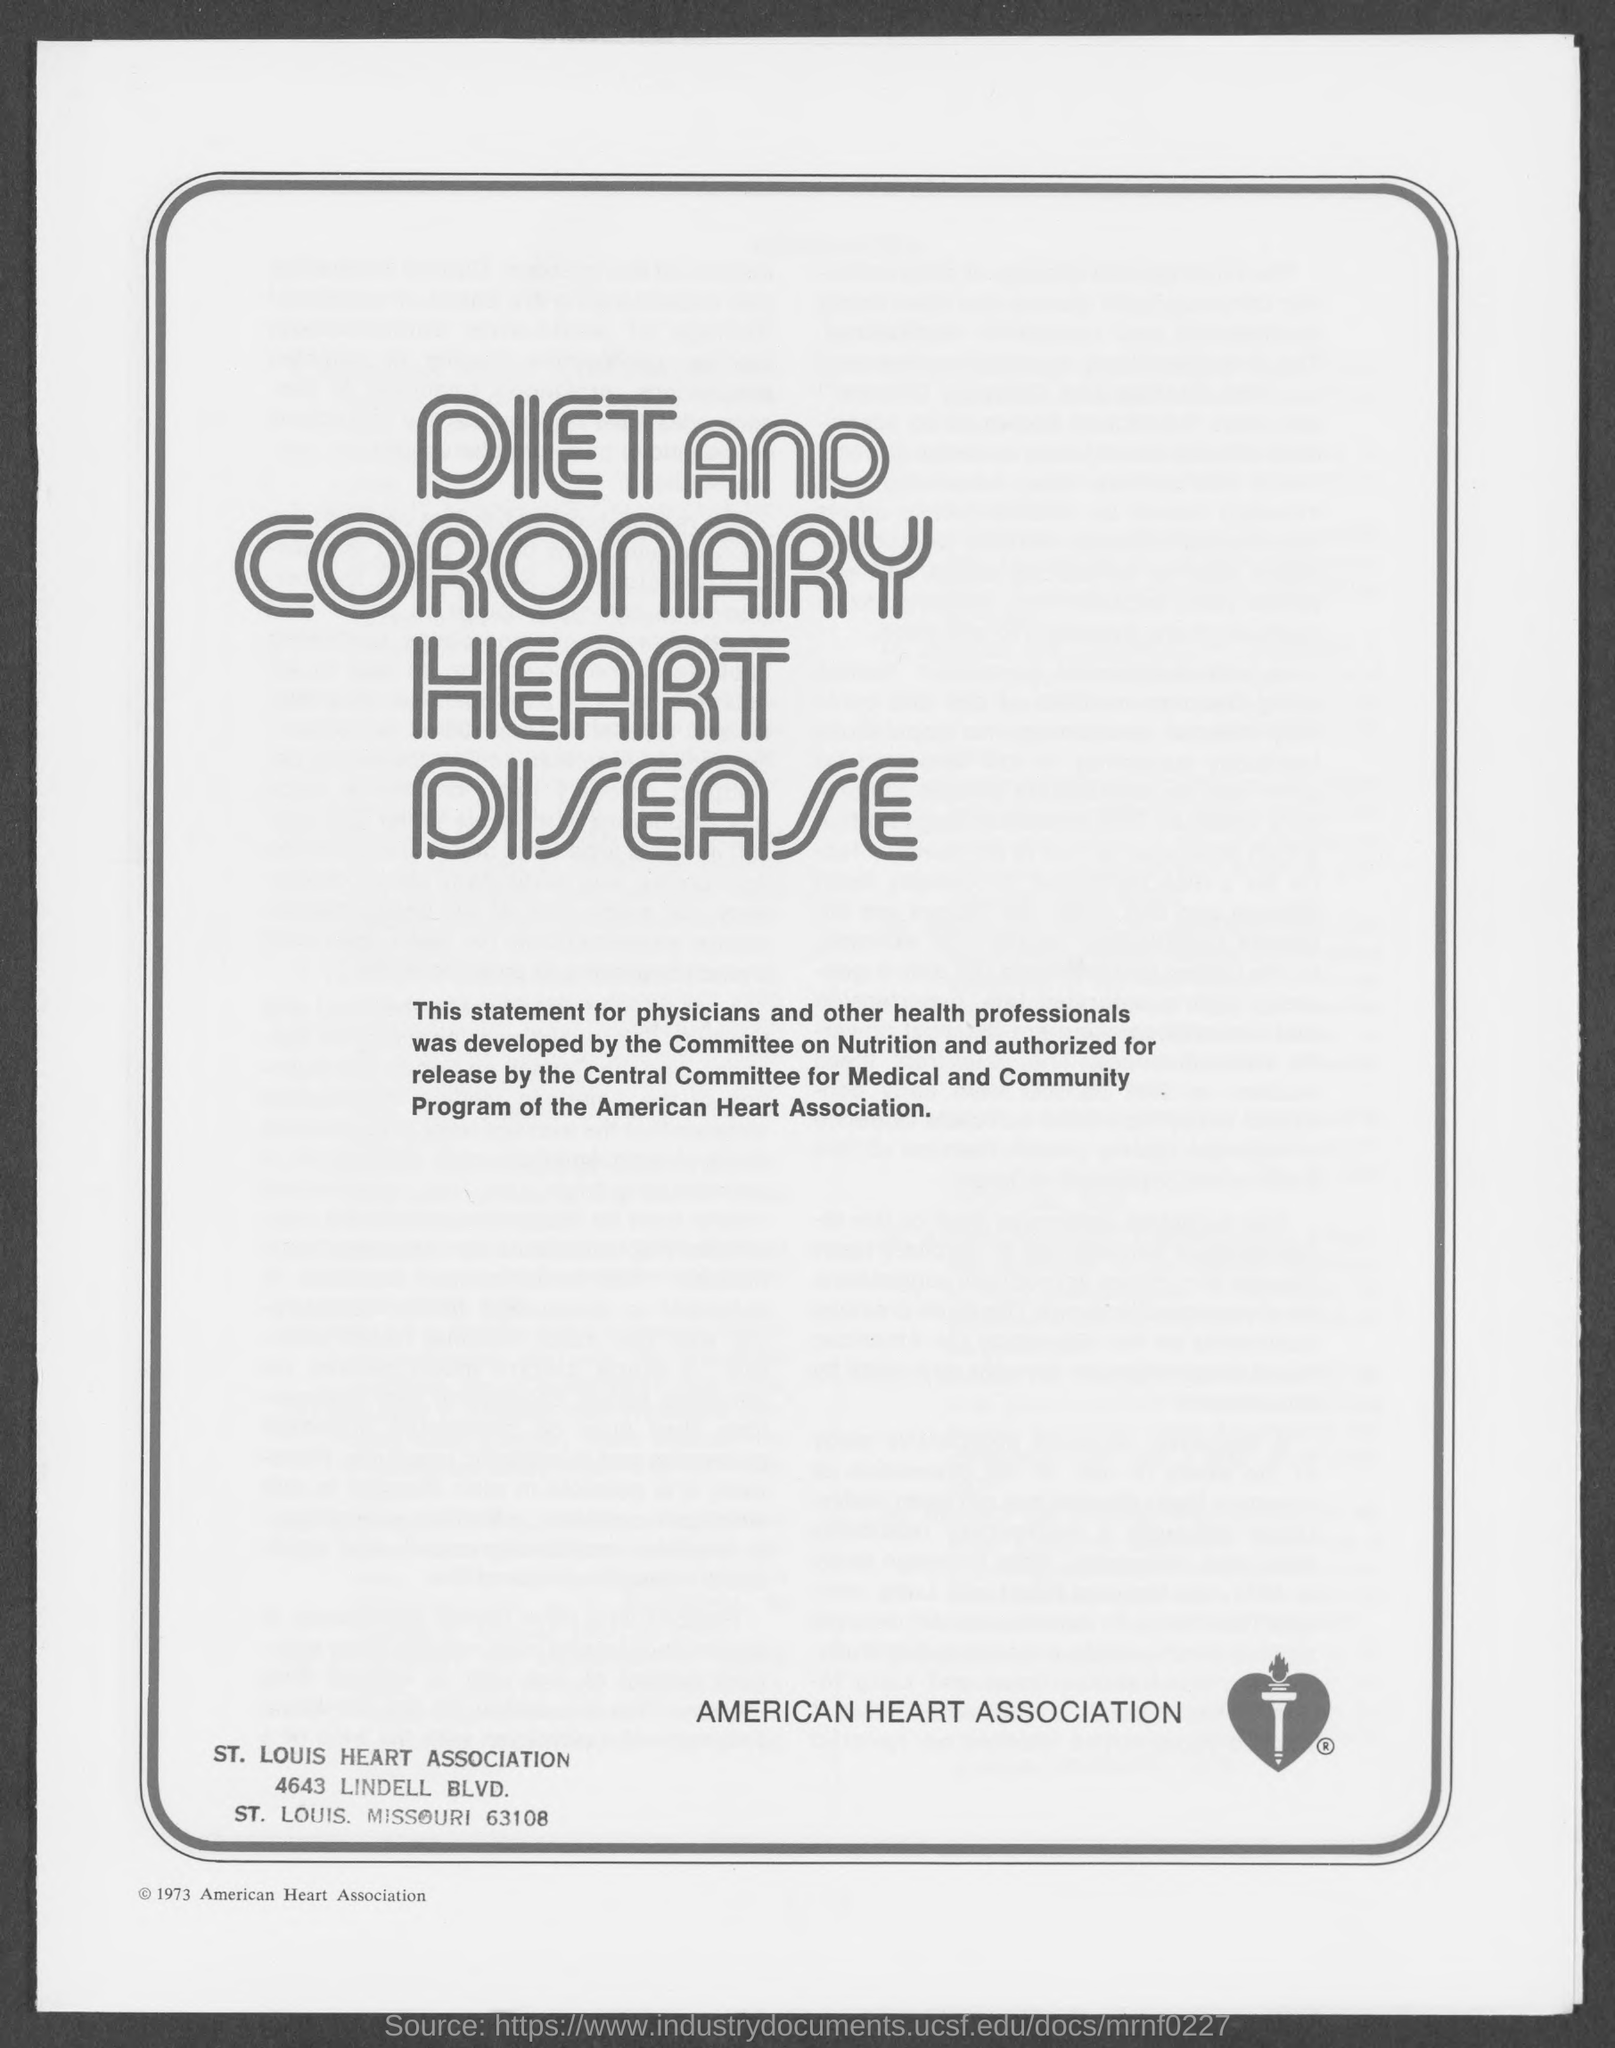Mention a couple of crucial points in this snapshot. The name of the organization dedicated to heart health is the American Heart Association. The street address of the St. Louis Heart Association is located at 4643 Lindell Boulevard. 